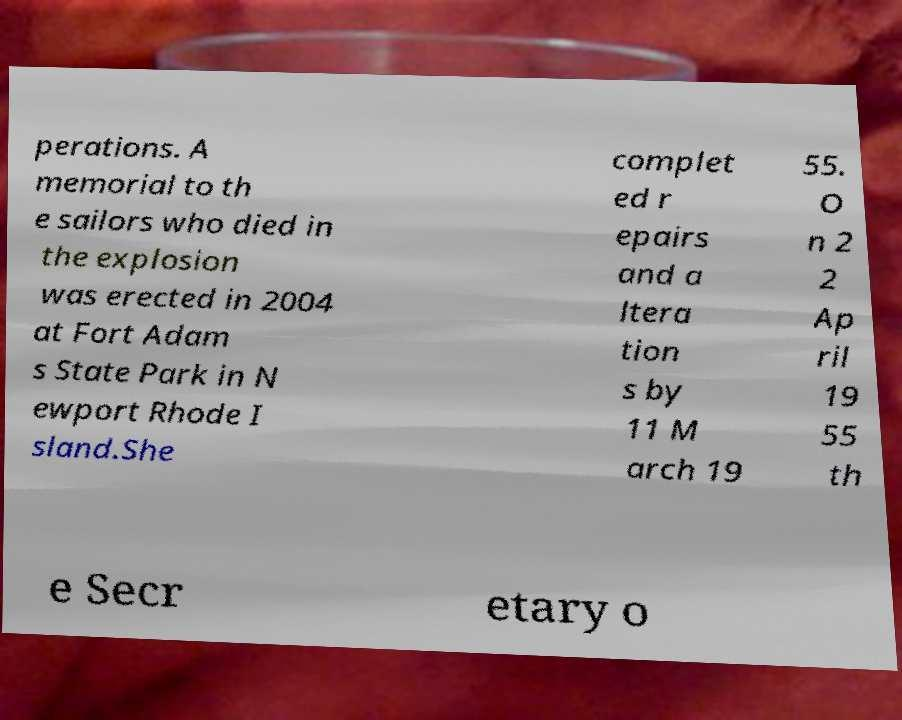Please identify and transcribe the text found in this image. perations. A memorial to th e sailors who died in the explosion was erected in 2004 at Fort Adam s State Park in N ewport Rhode I sland.She complet ed r epairs and a ltera tion s by 11 M arch 19 55. O n 2 2 Ap ril 19 55 th e Secr etary o 